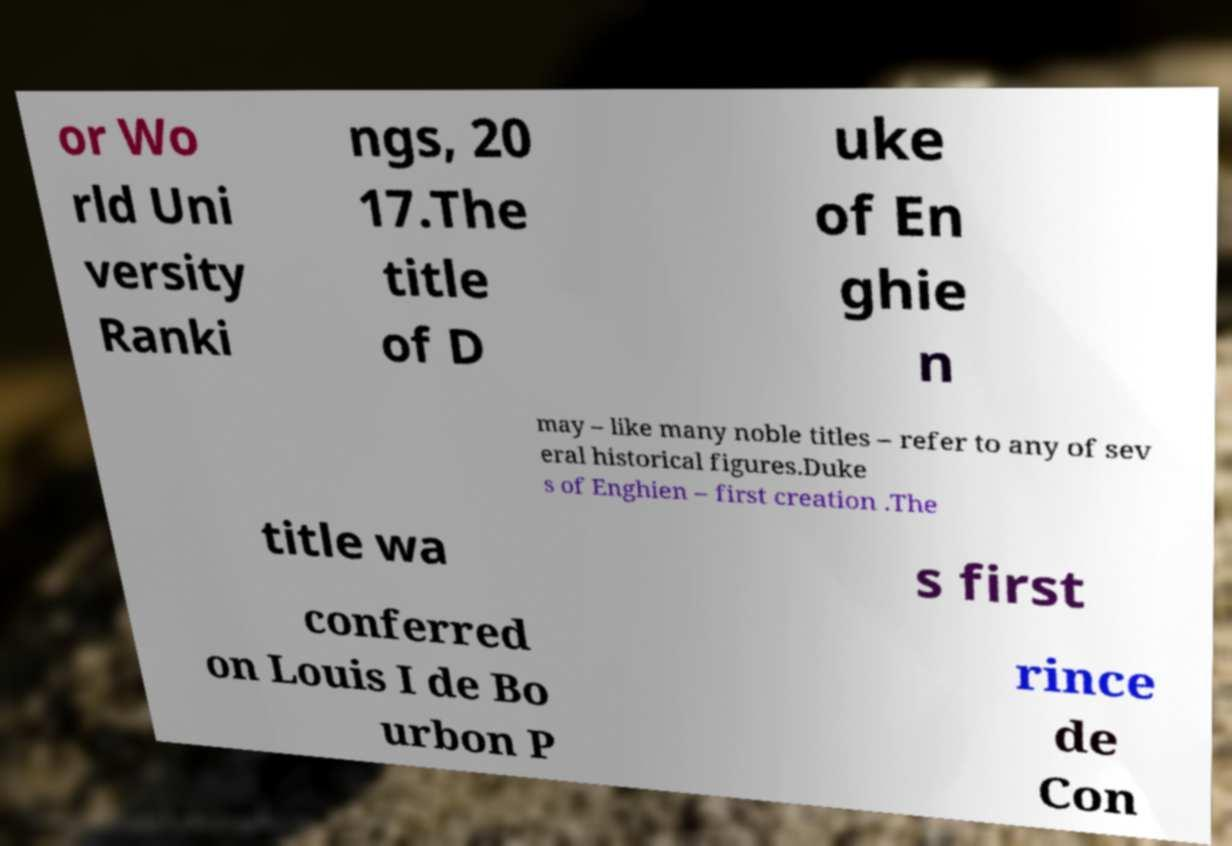What messages or text are displayed in this image? I need them in a readable, typed format. or Wo rld Uni versity Ranki ngs, 20 17.The title of D uke of En ghie n may – like many noble titles – refer to any of sev eral historical figures.Duke s of Enghien – first creation .The title wa s first conferred on Louis I de Bo urbon P rince de Con 